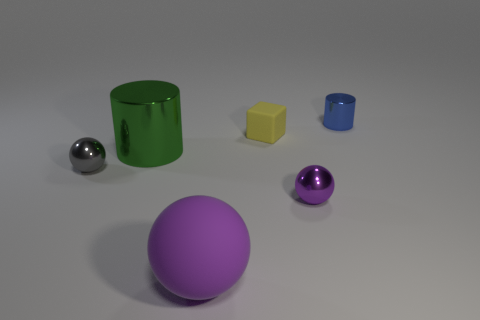What material is the thing that is the same color as the large sphere?
Your answer should be compact. Metal. Do the small ball that is left of the matte cube and the big green cylinder have the same material?
Provide a short and direct response. Yes. How many things are either tiny purple metallic objects in front of the big green metal thing or big shiny balls?
Your response must be concise. 1. There is a cube that is made of the same material as the large purple object; what is its color?
Your response must be concise. Yellow. Are there any purple spheres that have the same size as the gray object?
Offer a very short reply. Yes. Do the metal cylinder that is on the right side of the block and the tiny matte object have the same color?
Keep it short and to the point. No. There is a metallic thing that is both right of the purple matte thing and in front of the small yellow thing; what is its color?
Offer a very short reply. Purple. There is a purple object that is the same size as the blue thing; what shape is it?
Your answer should be compact. Sphere. Are there any other large purple things that have the same shape as the large rubber object?
Provide a short and direct response. No. There is a matte thing that is to the right of the matte ball; is it the same size as the big purple ball?
Offer a very short reply. No. 